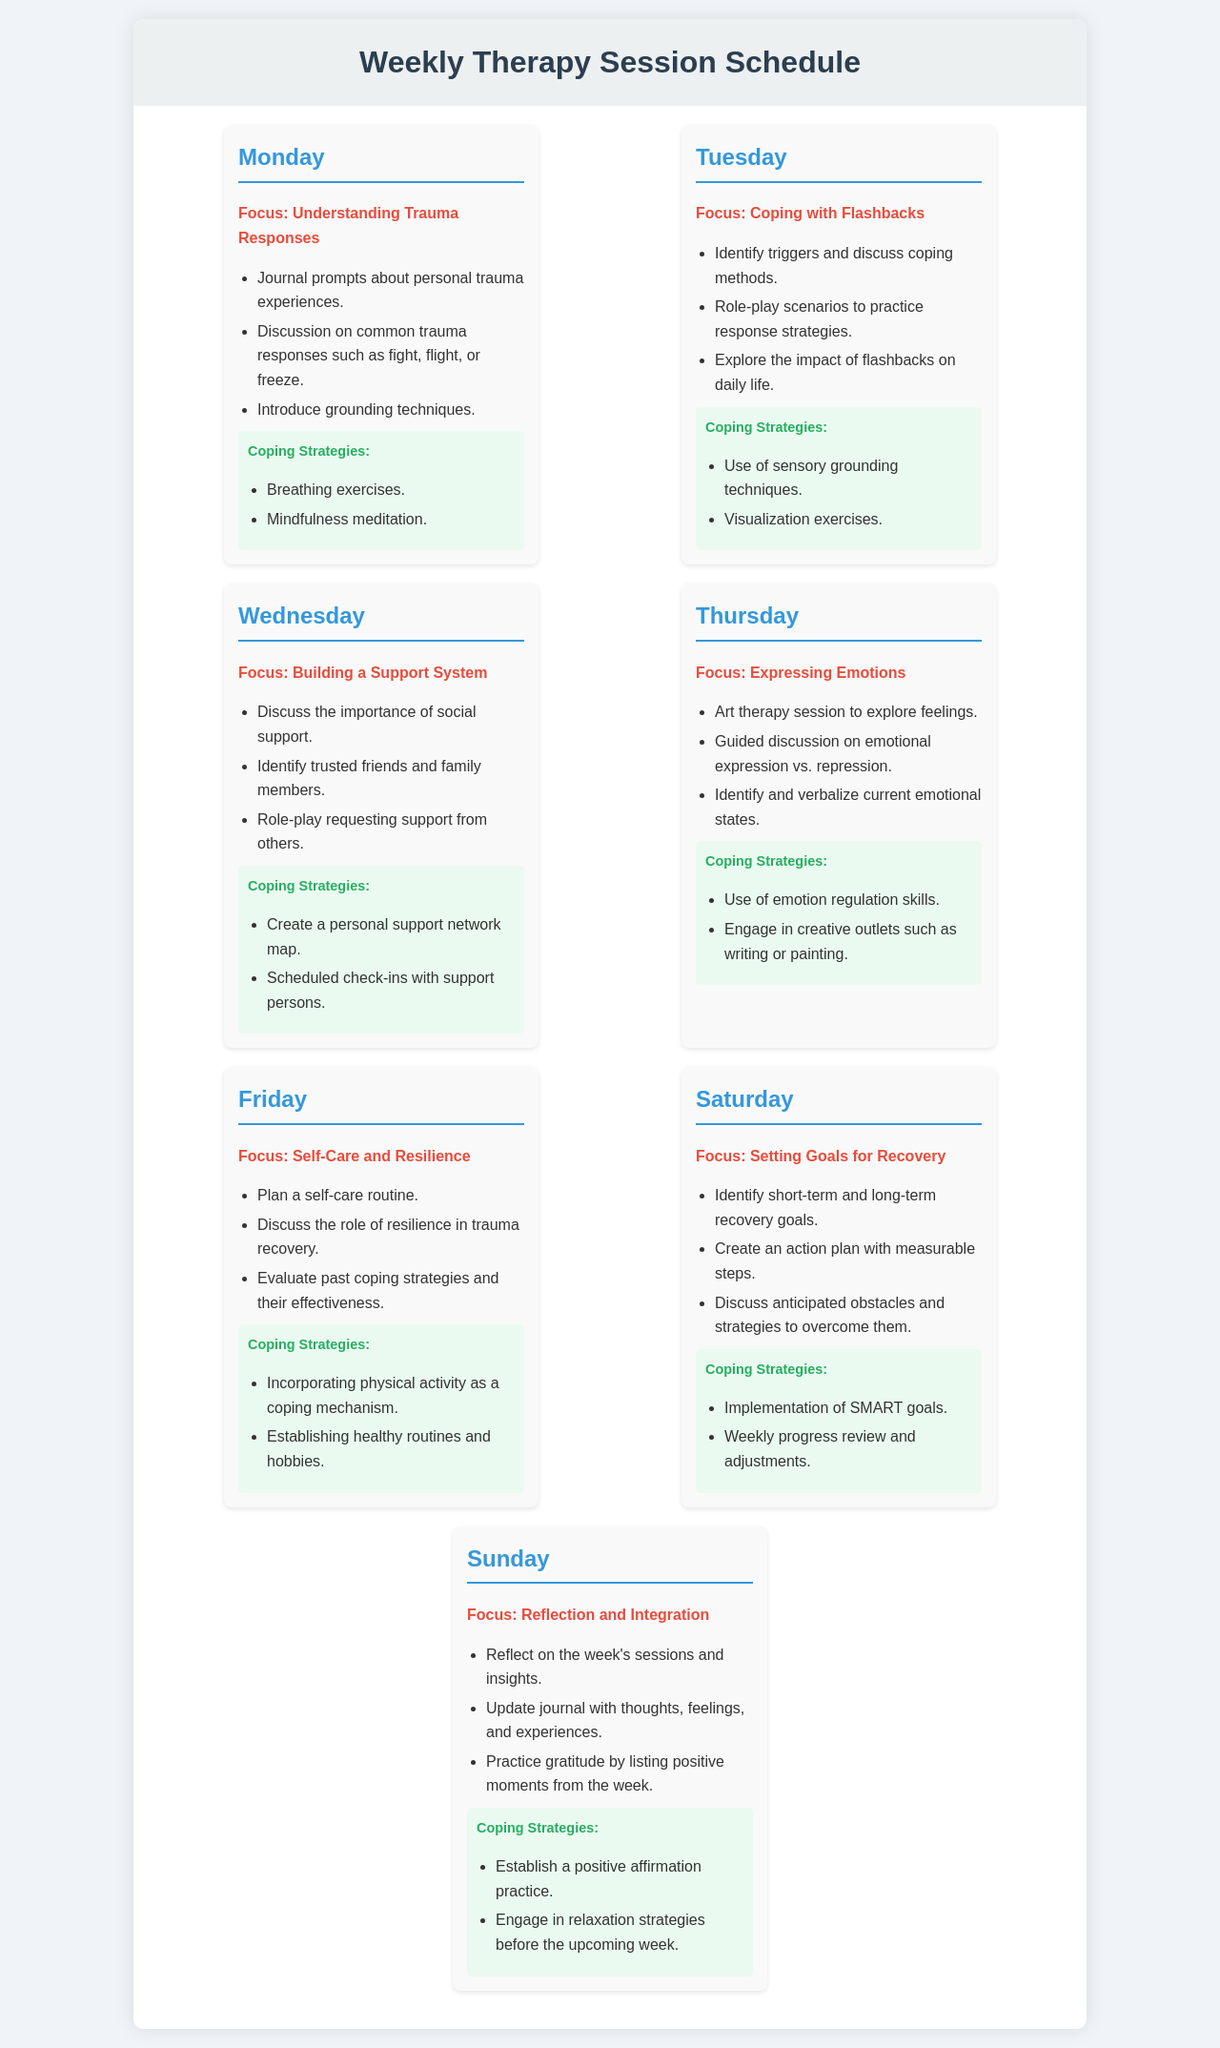What is the focus of Monday's session? The focus of Monday's session is clearly stated in the document as "Understanding Trauma Responses."
Answer: Understanding Trauma Responses List one coping strategy from Thursday's session. The document outlines coping strategies under each day's focus area; one strategy listed for Thursday is "Use of emotion regulation skills."
Answer: Use of emotion regulation skills How many coping strategies are provided for Saturday? The document provides a list of coping strategies specifically for Saturday, which includes two items.
Answer: 2 What activity is included in the Tuesday session? The Tuesday session includes role-playing scenarios to practice response strategies, which is included in the list for that day.
Answer: Role-play scenarios What is one of the focuses for Sunday? The focus for Sunday is identified in the document as "Reflection and Integration."
Answer: Reflection and Integration Which day discusses self-care routines? The day dedicated to discussing self-care routines is explicitly labeled as Friday in the document.
Answer: Friday Name one coping strategy recommended for managing flashbacks. The document lists "Use of sensory grounding techniques" as a coping strategy for managing flashbacks on Tuesday.
Answer: Use of sensory grounding techniques What is the action plan's focus on Saturday's session? The action plan for Saturday's session emphasizes identifying short-term and long-term recovery goals.
Answer: Identifying short-term and long-term recovery goals What type of techniques are introduced during Monday’s session? The techniques introduced on Monday focus on grounding techniques, as indicated in the session outline.
Answer: Grounding techniques 